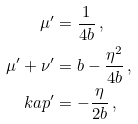<formula> <loc_0><loc_0><loc_500><loc_500>\mu ^ { \prime } & = \frac { 1 } { 4 b } \, , \\ \mu ^ { \prime } + \nu ^ { \prime } & = b - \frac { \eta ^ { 2 } } { 4 b } \, , \\ \ k a p ^ { \prime } & = - \frac { \eta } { 2 b } \, ,</formula> 